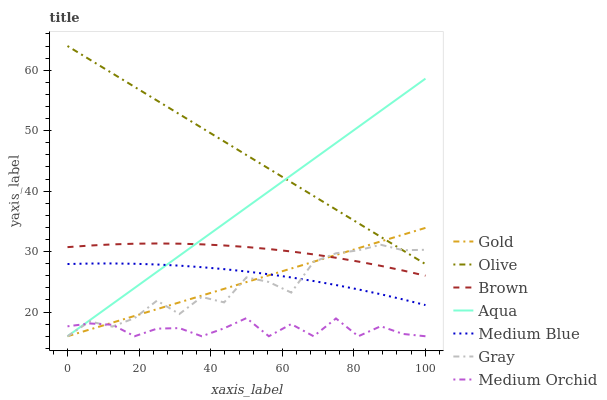Does Medium Orchid have the minimum area under the curve?
Answer yes or no. Yes. Does Olive have the maximum area under the curve?
Answer yes or no. Yes. Does Gold have the minimum area under the curve?
Answer yes or no. No. Does Gold have the maximum area under the curve?
Answer yes or no. No. Is Gold the smoothest?
Answer yes or no. Yes. Is Gray the roughest?
Answer yes or no. Yes. Is Gray the smoothest?
Answer yes or no. No. Is Gold the roughest?
Answer yes or no. No. Does Medium Blue have the lowest value?
Answer yes or no. No. Does Olive have the highest value?
Answer yes or no. Yes. Does Gold have the highest value?
Answer yes or no. No. Is Medium Orchid less than Medium Blue?
Answer yes or no. Yes. Is Brown greater than Medium Blue?
Answer yes or no. Yes. Does Medium Orchid intersect Medium Blue?
Answer yes or no. No. 